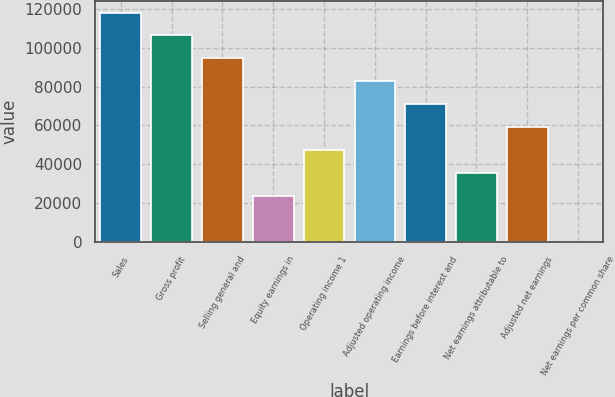<chart> <loc_0><loc_0><loc_500><loc_500><bar_chart><fcel>Sales<fcel>Gross profit<fcel>Selling general and<fcel>Equity earnings in<fcel>Operating income 1<fcel>Adjusted operating income<fcel>Earnings before interest and<fcel>Net earnings attributable to<fcel>Adjusted net earnings<fcel>Net earnings per common share<nl><fcel>118214<fcel>106393<fcel>94571.9<fcel>23645.8<fcel>47287.9<fcel>82750.9<fcel>70929.9<fcel>35466.8<fcel>59108.9<fcel>3.78<nl></chart> 